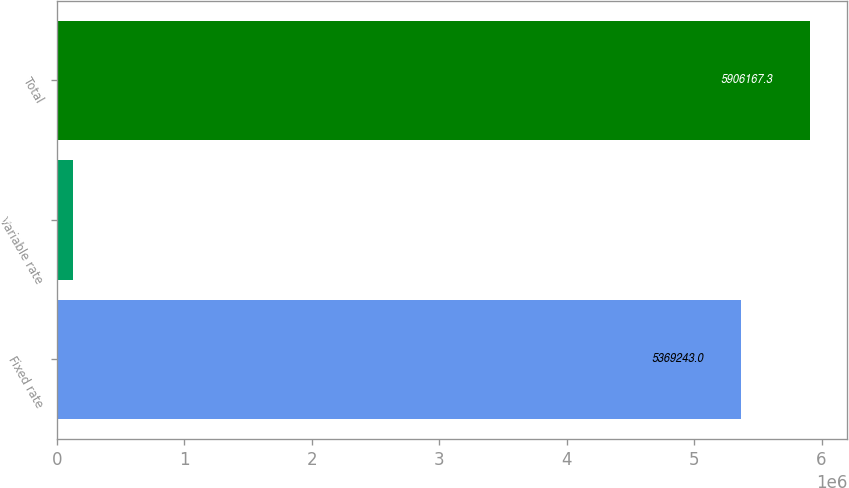<chart> <loc_0><loc_0><loc_500><loc_500><bar_chart><fcel>Fixed rate<fcel>Variable rate<fcel>Total<nl><fcel>5.36924e+06<fcel>122923<fcel>5.90617e+06<nl></chart> 